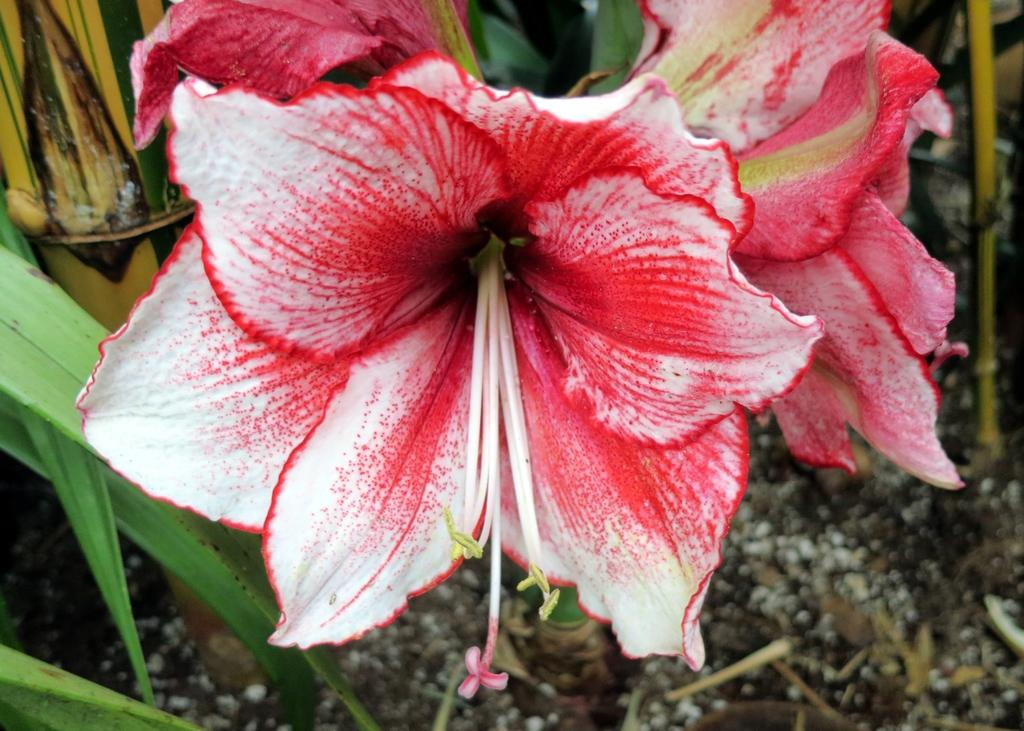What type of living organism can be seen in the image? The image contains a plant. What part of the plant is the main focus of the image? There are flowers in the center of the image. What is the base of the plant made of? There is soil at the bottom of the image. What song is the plant singing in the image? Plants do not sing songs, so there is no song being sung by the plant in the image. 